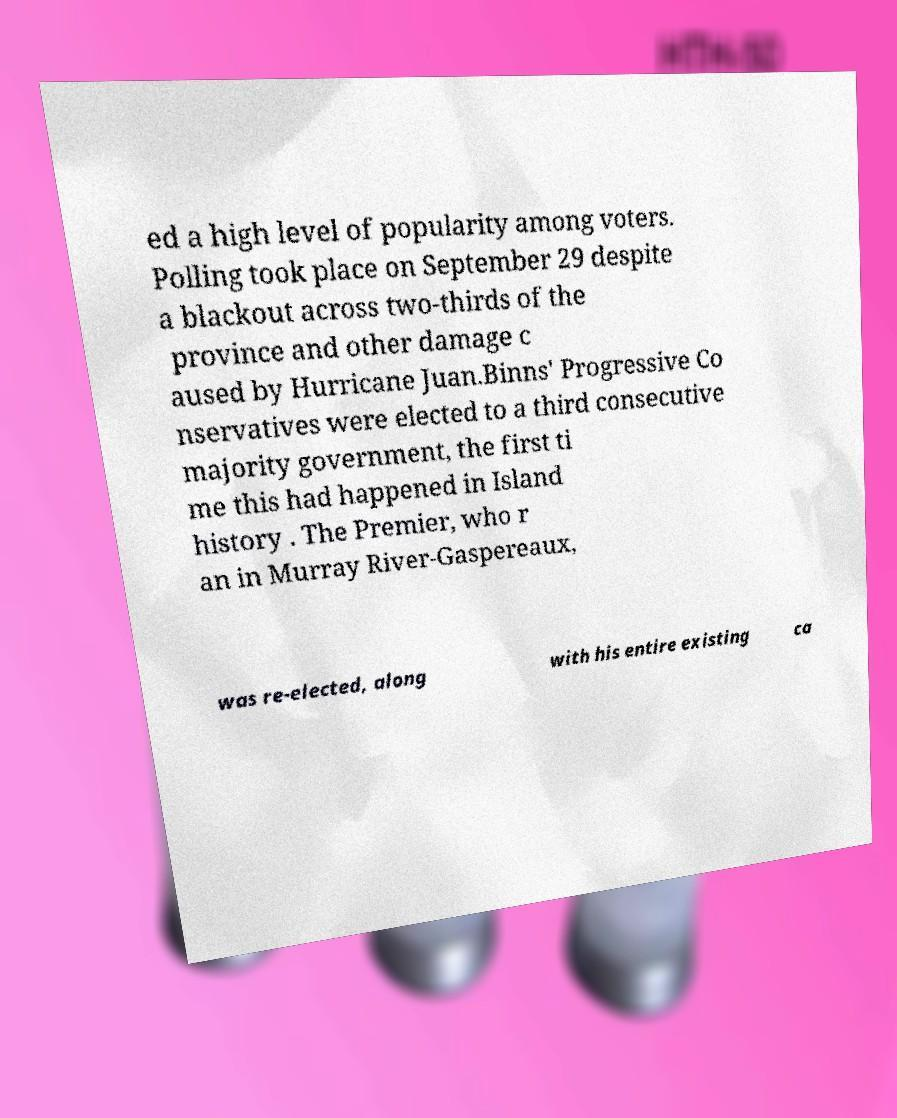Can you read and provide the text displayed in the image?This photo seems to have some interesting text. Can you extract and type it out for me? ed a high level of popularity among voters. Polling took place on September 29 despite a blackout across two-thirds of the province and other damage c aused by Hurricane Juan.Binns' Progressive Co nservatives were elected to a third consecutive majority government, the first ti me this had happened in Island history . The Premier, who r an in Murray River-Gaspereaux, was re-elected, along with his entire existing ca 